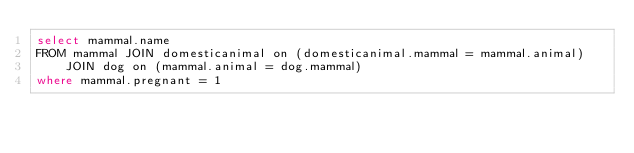<code> <loc_0><loc_0><loc_500><loc_500><_SQL_>select mammal.name
FROM mammal JOIN domesticanimal on (domesticanimal.mammal = mammal.animal)
    JOIN dog on (mammal.animal = dog.mammal)
where mammal.pregnant = 1</code> 